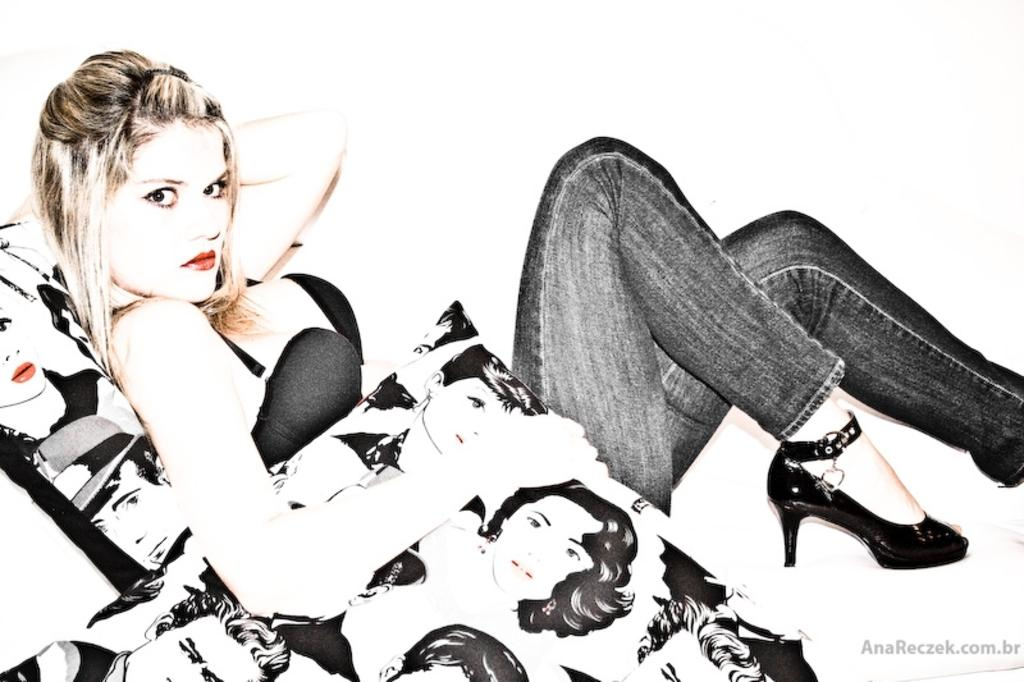Who is the main subject in the image? There is a lady in the image. What is the lady doing in the image? The lady is sitting on a sofa. What is the lady holding in her hand? The lady is holding a cushion in her hand. What type of rake is the lady using to clean the floor in the image? There is no rake present in the image, and the lady is not cleaning the floor. 